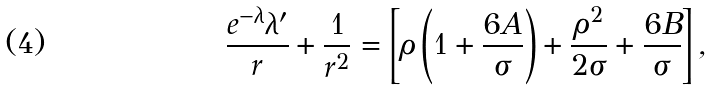Convert formula to latex. <formula><loc_0><loc_0><loc_500><loc_500>\frac { e ^ { - \lambda } \lambda ^ { \prime } } { r } + \frac { 1 } { r ^ { 2 } } = \left [ \rho \left ( 1 + \frac { 6 A } { \sigma } \right ) + \frac { \rho ^ { 2 } } { 2 \sigma } + \frac { 6 B } { \sigma } \right ] ,</formula> 